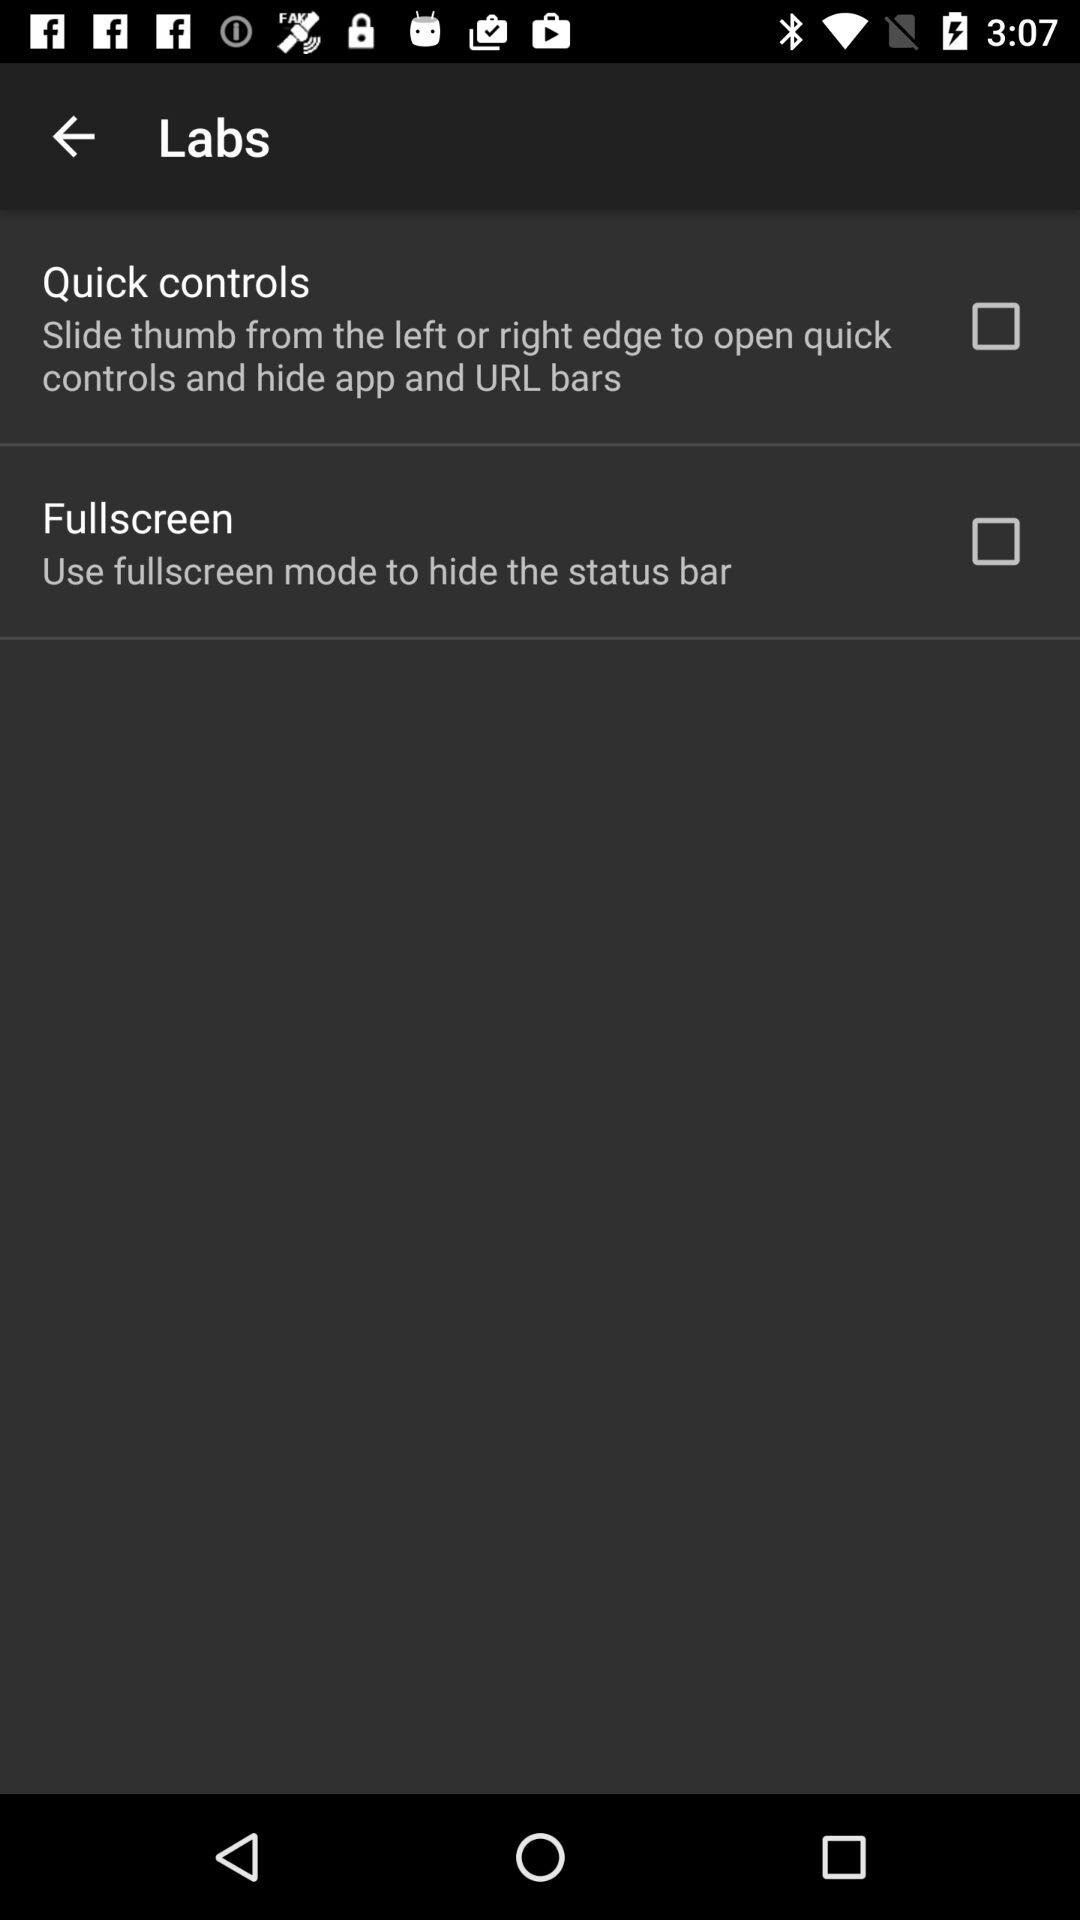What is the status of "Quick controls"? The status of "Quick controls" is "off". 